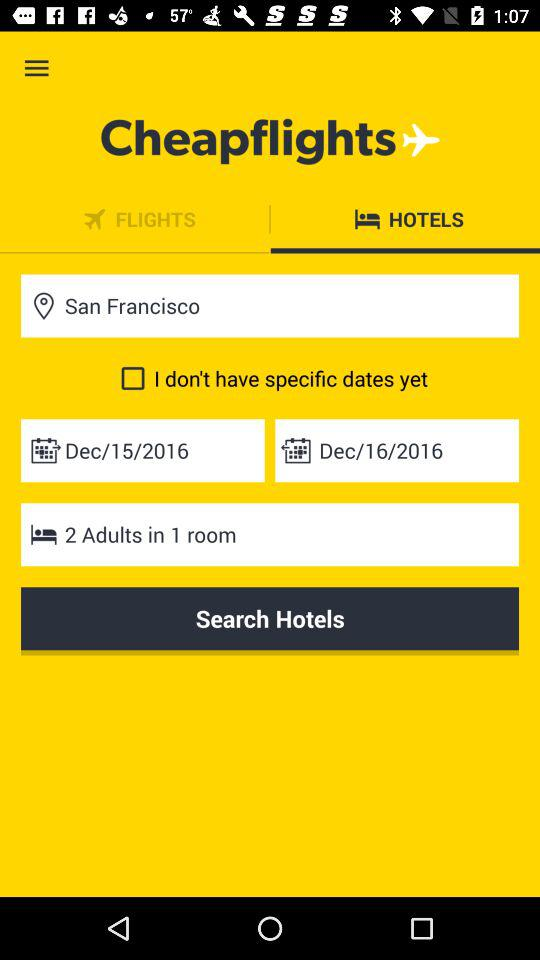How many adults are staying in the hotel?
Answer the question using a single word or phrase. 2 